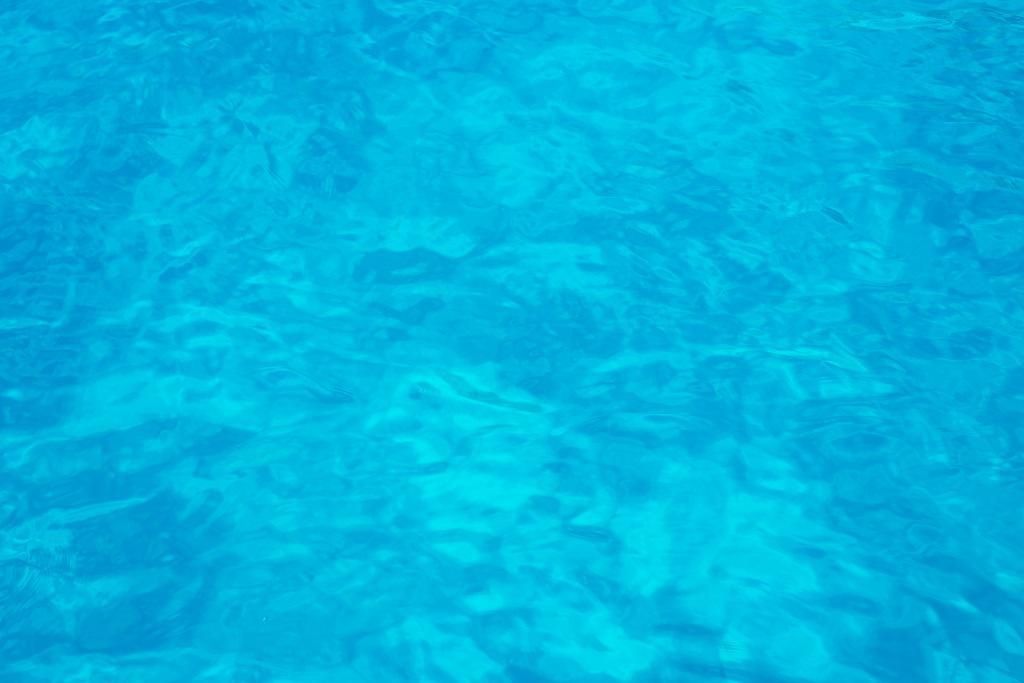Can you describe this image briefly? In this image there is a blue color surface. 